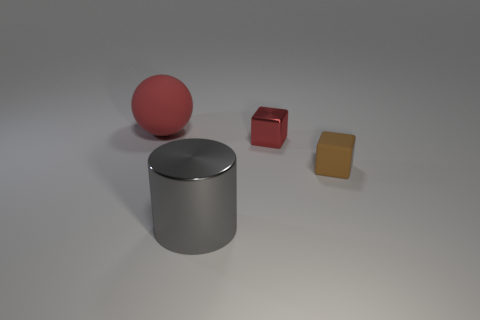What materials do the objects in the image appear to be made of? The objects in the image exhibit different textures and reflections. The spherical object and the small cube seem to have a matte finish, suggesting a possibly plastic or painted surface. The tiny red cube and the large cylinder appear to have a metallic sheen, indicating they might be made of metal. 